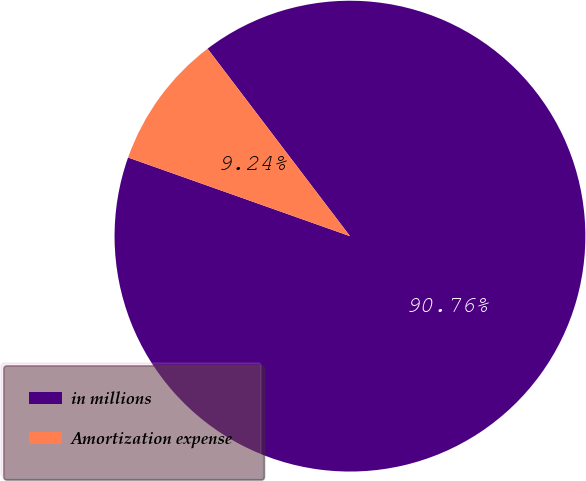Convert chart to OTSL. <chart><loc_0><loc_0><loc_500><loc_500><pie_chart><fcel>in millions<fcel>Amortization expense<nl><fcel>90.76%<fcel>9.24%<nl></chart> 